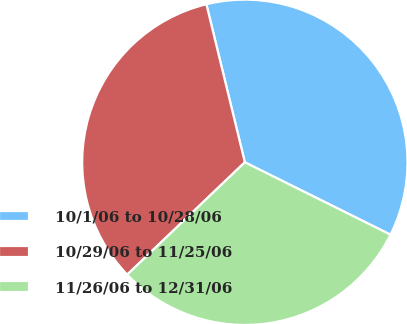<chart> <loc_0><loc_0><loc_500><loc_500><pie_chart><fcel>10/1/06 to 10/28/06<fcel>10/29/06 to 11/25/06<fcel>11/26/06 to 12/31/06<nl><fcel>36.14%<fcel>33.33%<fcel>30.52%<nl></chart> 